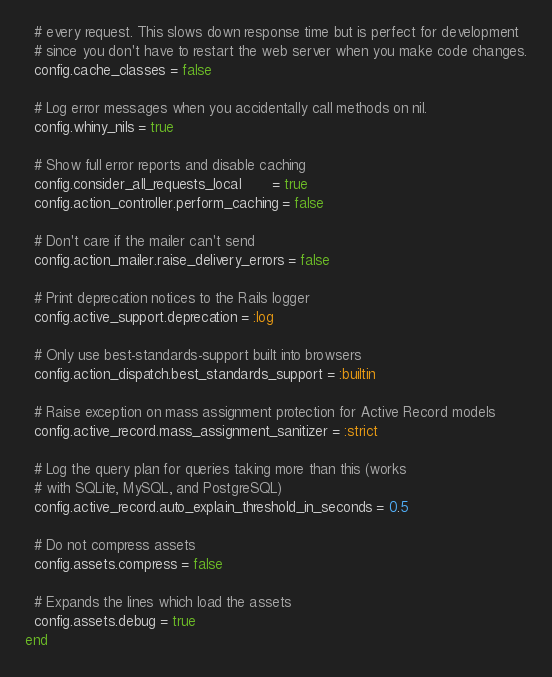Convert code to text. <code><loc_0><loc_0><loc_500><loc_500><_Ruby_>  # every request. This slows down response time but is perfect for development
  # since you don't have to restart the web server when you make code changes.
  config.cache_classes = false

  # Log error messages when you accidentally call methods on nil.
  config.whiny_nils = true

  # Show full error reports and disable caching
  config.consider_all_requests_local       = true
  config.action_controller.perform_caching = false

  # Don't care if the mailer can't send
  config.action_mailer.raise_delivery_errors = false

  # Print deprecation notices to the Rails logger
  config.active_support.deprecation = :log

  # Only use best-standards-support built into browsers
  config.action_dispatch.best_standards_support = :builtin

  # Raise exception on mass assignment protection for Active Record models
  config.active_record.mass_assignment_sanitizer = :strict

  # Log the query plan for queries taking more than this (works
  # with SQLite, MySQL, and PostgreSQL)
  config.active_record.auto_explain_threshold_in_seconds = 0.5

  # Do not compress assets
  config.assets.compress = false

  # Expands the lines which load the assets
  config.assets.debug = true
end
</code> 